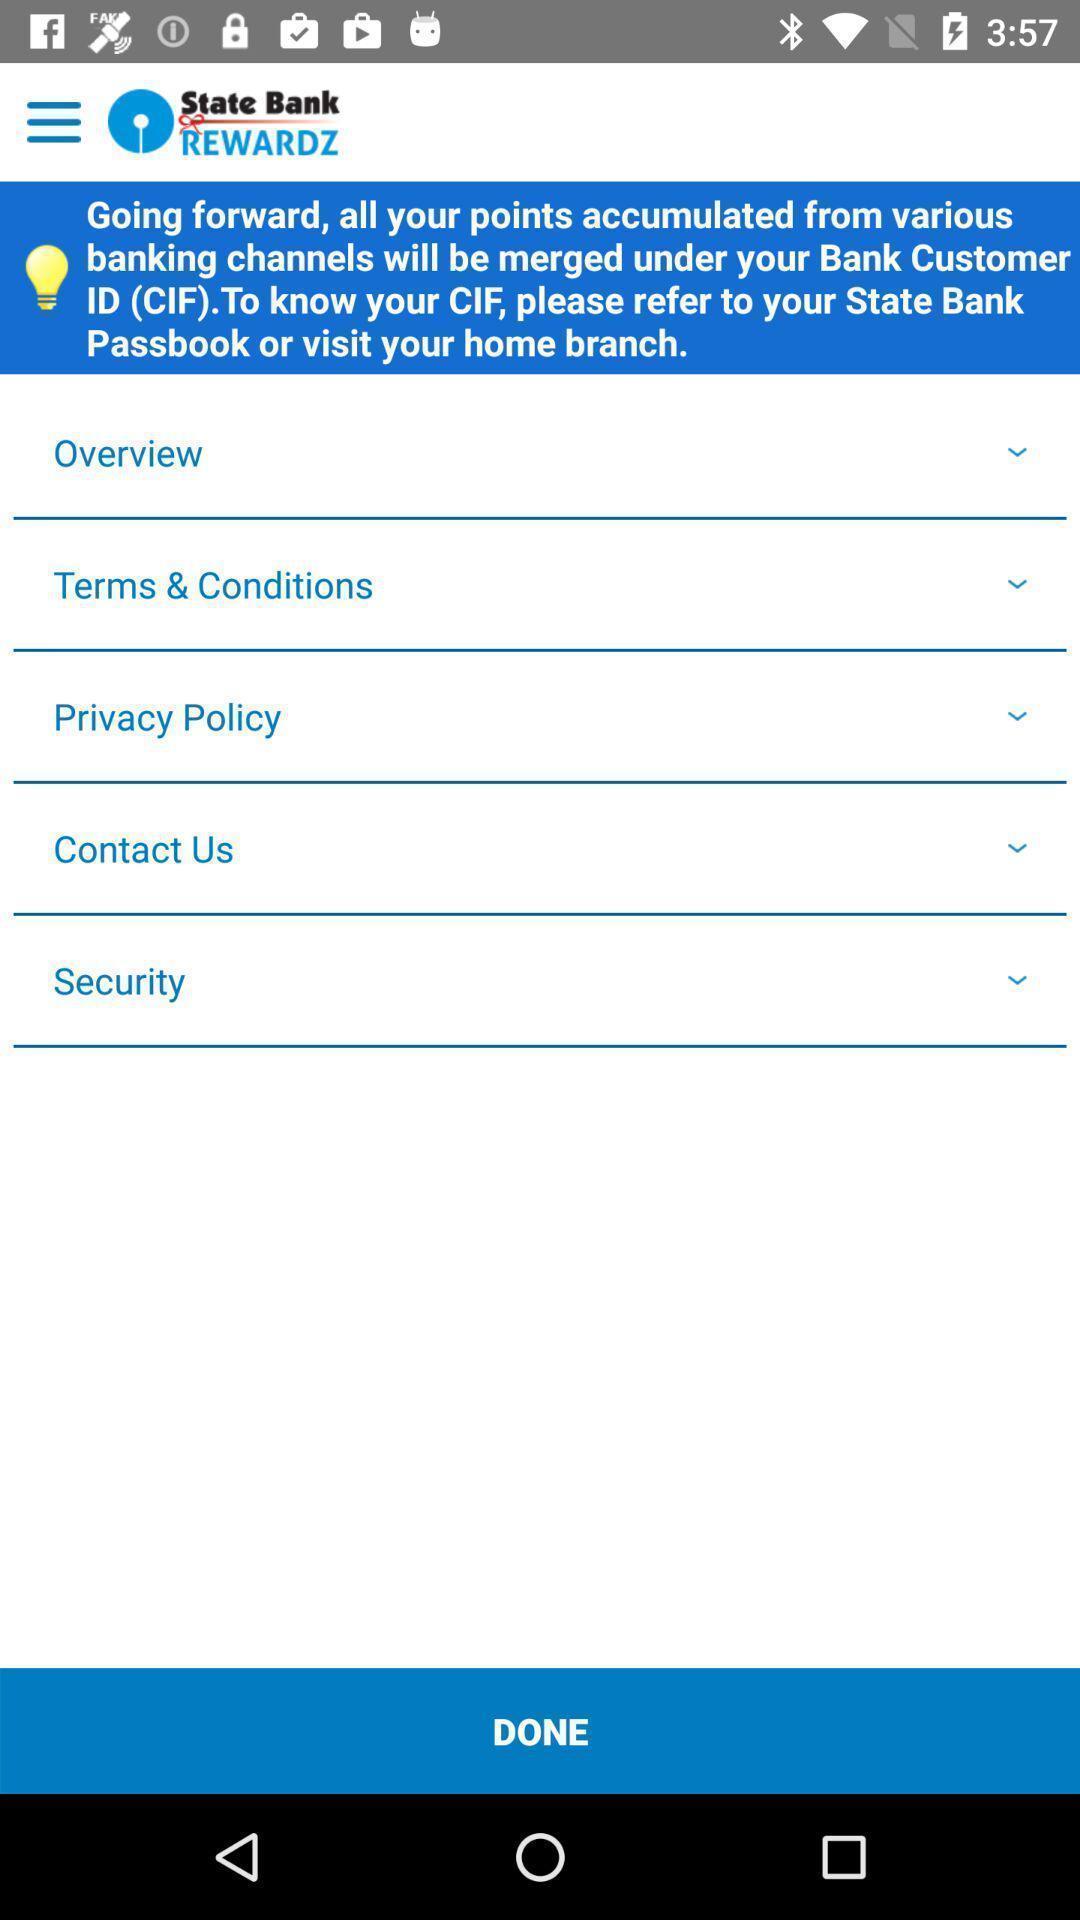What can you discern from this picture? Page showing various categories of bank app. 